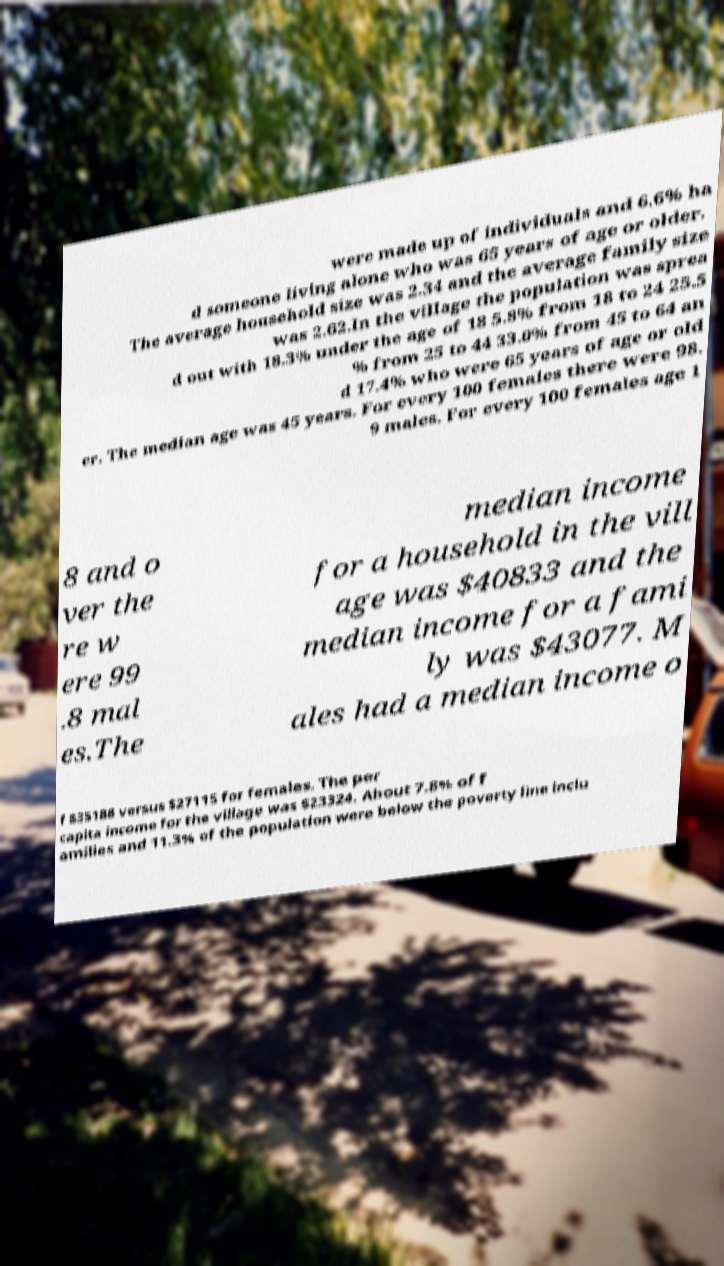Can you accurately transcribe the text from the provided image for me? were made up of individuals and 6.6% ha d someone living alone who was 65 years of age or older. The average household size was 2.34 and the average family size was 2.62.In the village the population was sprea d out with 18.3% under the age of 18 5.8% from 18 to 24 25.5 % from 25 to 44 33.0% from 45 to 64 an d 17.4% who were 65 years of age or old er. The median age was 45 years. For every 100 females there were 98. 9 males. For every 100 females age 1 8 and o ver the re w ere 99 .8 mal es.The median income for a household in the vill age was $40833 and the median income for a fami ly was $43077. M ales had a median income o f $35188 versus $27115 for females. The per capita income for the village was $23324. About 7.8% of f amilies and 11.3% of the population were below the poverty line inclu 